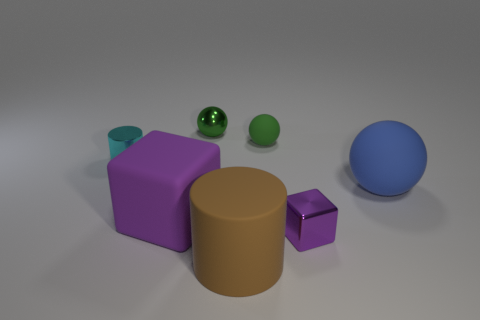Subtract all big spheres. How many spheres are left? 2 Subtract all cyan cylinders. How many green spheres are left? 2 Add 3 small gray blocks. How many objects exist? 10 Subtract all big objects. Subtract all cyan metallic objects. How many objects are left? 3 Add 7 purple metallic things. How many purple metallic things are left? 8 Add 2 big purple objects. How many big purple objects exist? 3 Subtract 0 yellow cylinders. How many objects are left? 7 Subtract all blocks. How many objects are left? 5 Subtract all brown spheres. Subtract all cyan cylinders. How many spheres are left? 3 